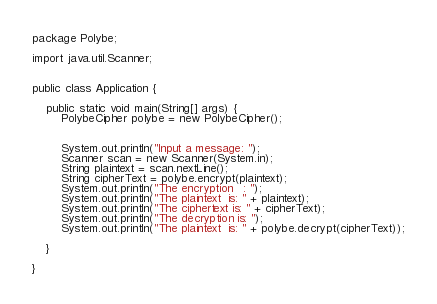Convert code to text. <code><loc_0><loc_0><loc_500><loc_500><_Java_>package Polybe;

import java.util.Scanner;


public class Application {

	public static void main(String[] args) {
		PolybeCipher polybe = new PolybeCipher();
		
		
		System.out.println("Input a message: ");
		Scanner scan = new Scanner(System.in);
		String plaintext = scan.nextLine();
		String cipherText = polybe.encrypt(plaintext);
		System.out.println("The encryption   : ");
		System.out.println("The plaintext  is: " + plaintext);
		System.out.println("The ciphertext is: " + cipherText);
		System.out.println("The decryption is: ");
		System.out.println("The plaintext  is: " + polybe.decrypt(cipherText));

	}

}
</code> 